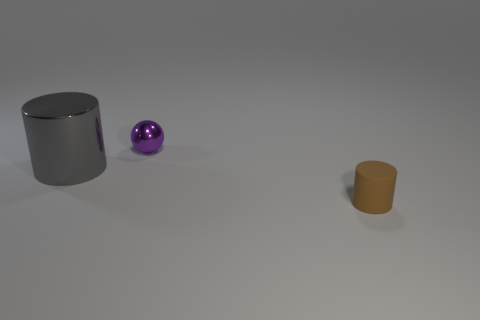Add 2 purple things. How many objects exist? 5 Subtract 0 cyan cylinders. How many objects are left? 3 Subtract all spheres. How many objects are left? 2 Subtract all big cylinders. Subtract all big cylinders. How many objects are left? 1 Add 1 small purple metallic objects. How many small purple metallic objects are left? 2 Add 2 large yellow shiny cylinders. How many large yellow shiny cylinders exist? 2 